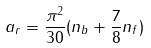Convert formula to latex. <formula><loc_0><loc_0><loc_500><loc_500>a _ { r } = { \frac { \pi ^ { 2 } } { 3 0 } } ( n _ { b } + { \frac { 7 } { 8 } } n _ { f } )</formula> 